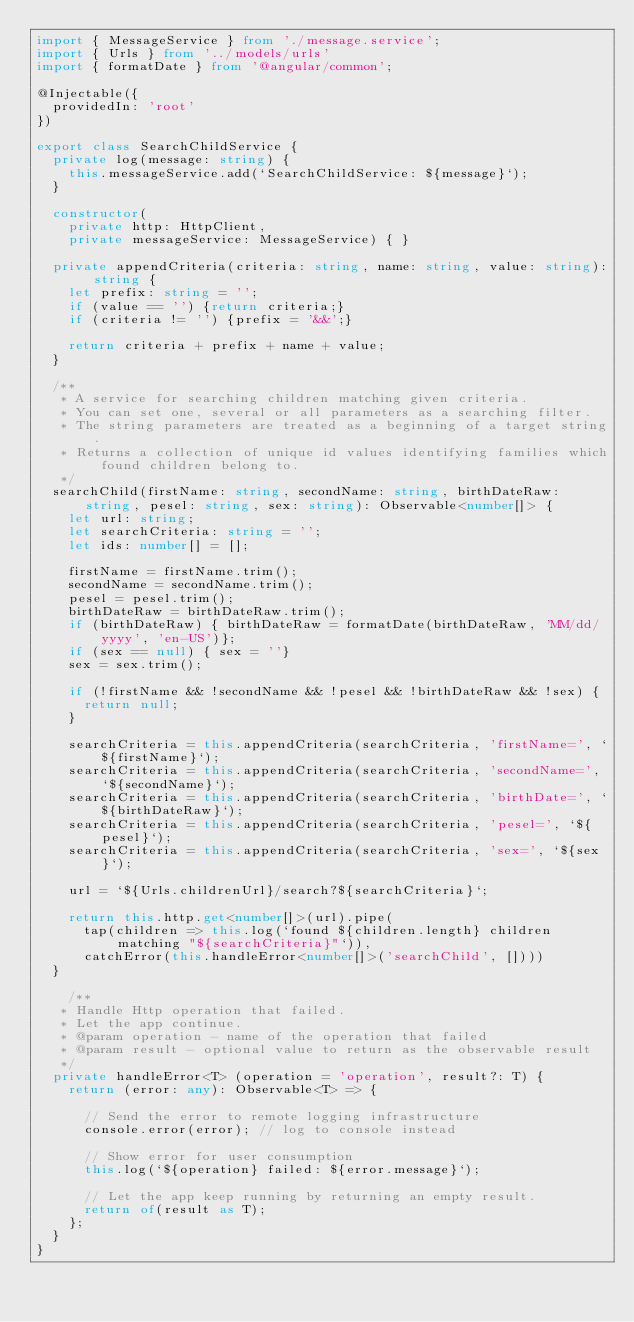Convert code to text. <code><loc_0><loc_0><loc_500><loc_500><_TypeScript_>import { MessageService } from './message.service';
import { Urls } from '../models/urls'
import { formatDate } from '@angular/common';

@Injectable({
  providedIn: 'root'
})

export class SearchChildService {
  private log(message: string) {
    this.messageService.add(`SearchChildService: ${message}`);
  }
  
  constructor(
    private http: HttpClient,
    private messageService: MessageService) { }

  private appendCriteria(criteria: string, name: string, value: string): string {
    let prefix: string = '';
    if (value == '') {return criteria;}
    if (criteria != '') {prefix = '&&';}

    return criteria + prefix + name + value;
  }

	/**
	 * A service for searching children matching given criteria.
	 * You can set one, several or all parameters as a searching filter.
	 * The string parameters are treated as a beginning of a target string.
	 * Returns a collection of unique id values identifying families which found children belong to. 
	 */
  searchChild(firstName: string, secondName: string, birthDateRaw: string, pesel: string, sex: string): Observable<number[]> {
    let url: string;
    let searchCriteria: string = '';
    let ids: number[] = [];

    firstName = firstName.trim();
    secondName = secondName.trim();
    pesel = pesel.trim();
    birthDateRaw = birthDateRaw.trim();
    if (birthDateRaw) { birthDateRaw = formatDate(birthDateRaw, 'MM/dd/yyyy', 'en-US')};
    if (sex == null) { sex = ''}
    sex = sex.trim();
  
    if (!firstName && !secondName && !pesel && !birthDateRaw && !sex) {
      return null;
    }

    searchCriteria = this.appendCriteria(searchCriteria, 'firstName=', `${firstName}`);
    searchCriteria = this.appendCriteria(searchCriteria, 'secondName=', `${secondName}`);
    searchCriteria = this.appendCriteria(searchCriteria, 'birthDate=', `${birthDateRaw}`);
    searchCriteria = this.appendCriteria(searchCriteria, 'pesel=', `${pesel}`);
    searchCriteria = this.appendCriteria(searchCriteria, 'sex=', `${sex}`);

    url = `${Urls.childrenUrl}/search?${searchCriteria}`;

    return this.http.get<number[]>(url).pipe(
      tap(children => this.log(`found ${children.length} children matching "${searchCriteria}"`)),
      catchError(this.handleError<number[]>('searchChild', [])))
  }

    /**
   * Handle Http operation that failed.
   * Let the app continue.
   * @param operation - name of the operation that failed
   * @param result - optional value to return as the observable result
   */
  private handleError<T> (operation = 'operation', result?: T) {
    return (error: any): Observable<T> => {
  
      // Send the error to remote logging infrastructure
      console.error(error); // log to console instead
  
      // Show error for user consumption
      this.log(`${operation} failed: ${error.message}`);

      // Let the app keep running by returning an empty result.
      return of(result as T);
    };
  }
}
</code> 